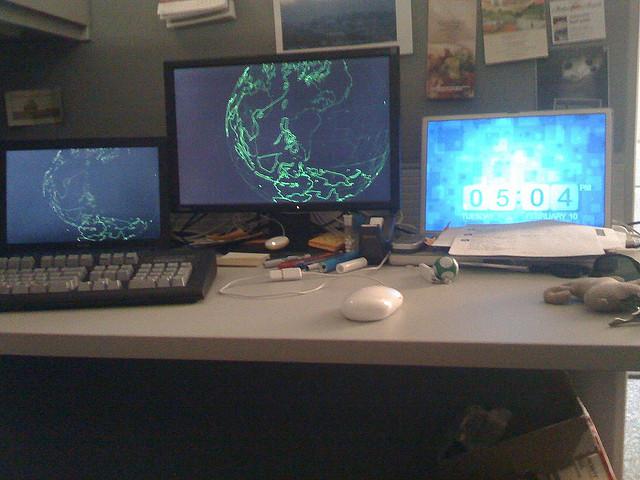Is there a calculator on the desk?
Write a very short answer. No. How many computer monitors are on this desk?
Keep it brief. 3. Where is the mouse?
Concise answer only. On desk. Is that a new mouse?
Keep it brief. Yes. What time is on the computer screen?
Keep it brief. 5:04. 